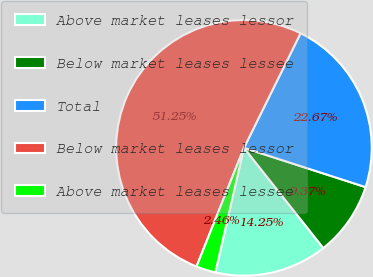Convert chart to OTSL. <chart><loc_0><loc_0><loc_500><loc_500><pie_chart><fcel>Above market leases lessor<fcel>Below market leases lessee<fcel>Total<fcel>Below market leases lessor<fcel>Above market leases lessee<nl><fcel>14.25%<fcel>9.37%<fcel>22.67%<fcel>51.26%<fcel>2.46%<nl></chart> 